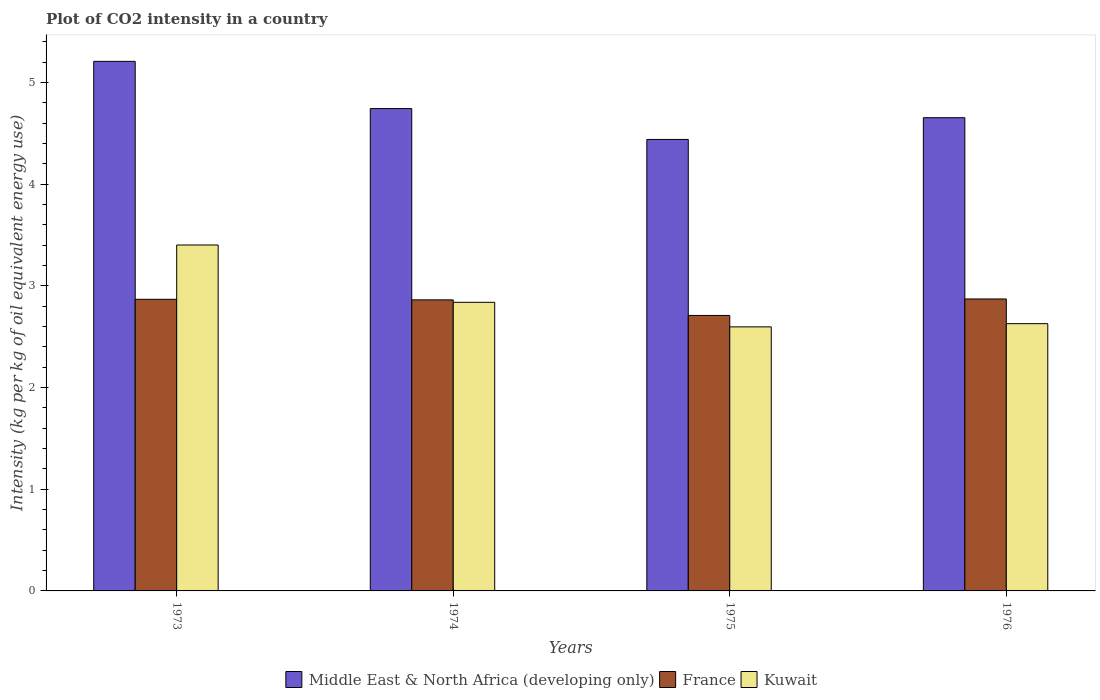How many different coloured bars are there?
Offer a very short reply. 3. How many groups of bars are there?
Give a very brief answer. 4. Are the number of bars per tick equal to the number of legend labels?
Give a very brief answer. Yes. Are the number of bars on each tick of the X-axis equal?
Provide a succinct answer. Yes. How many bars are there on the 2nd tick from the right?
Provide a short and direct response. 3. What is the label of the 4th group of bars from the left?
Offer a terse response. 1976. In how many cases, is the number of bars for a given year not equal to the number of legend labels?
Offer a terse response. 0. What is the CO2 intensity in in France in 1973?
Provide a succinct answer. 2.87. Across all years, what is the maximum CO2 intensity in in France?
Your answer should be very brief. 2.87. Across all years, what is the minimum CO2 intensity in in Middle East & North Africa (developing only)?
Offer a very short reply. 4.44. In which year was the CO2 intensity in in Middle East & North Africa (developing only) minimum?
Keep it short and to the point. 1975. What is the total CO2 intensity in in Middle East & North Africa (developing only) in the graph?
Make the answer very short. 19.05. What is the difference between the CO2 intensity in in Kuwait in 1973 and that in 1976?
Give a very brief answer. 0.77. What is the difference between the CO2 intensity in in Kuwait in 1975 and the CO2 intensity in in Middle East & North Africa (developing only) in 1973?
Ensure brevity in your answer.  -2.61. What is the average CO2 intensity in in France per year?
Give a very brief answer. 2.83. In the year 1973, what is the difference between the CO2 intensity in in Kuwait and CO2 intensity in in Middle East & North Africa (developing only)?
Keep it short and to the point. -1.81. What is the ratio of the CO2 intensity in in Middle East & North Africa (developing only) in 1973 to that in 1976?
Your answer should be compact. 1.12. Is the CO2 intensity in in Middle East & North Africa (developing only) in 1973 less than that in 1975?
Your answer should be compact. No. Is the difference between the CO2 intensity in in Kuwait in 1974 and 1975 greater than the difference between the CO2 intensity in in Middle East & North Africa (developing only) in 1974 and 1975?
Your answer should be very brief. No. What is the difference between the highest and the second highest CO2 intensity in in France?
Your answer should be very brief. 0. What is the difference between the highest and the lowest CO2 intensity in in France?
Your answer should be compact. 0.16. Is the sum of the CO2 intensity in in Middle East & North Africa (developing only) in 1973 and 1976 greater than the maximum CO2 intensity in in Kuwait across all years?
Ensure brevity in your answer.  Yes. What does the 1st bar from the left in 1976 represents?
Provide a succinct answer. Middle East & North Africa (developing only). What does the 1st bar from the right in 1975 represents?
Offer a terse response. Kuwait. Is it the case that in every year, the sum of the CO2 intensity in in France and CO2 intensity in in Kuwait is greater than the CO2 intensity in in Middle East & North Africa (developing only)?
Offer a terse response. Yes. Are all the bars in the graph horizontal?
Ensure brevity in your answer.  No. Are the values on the major ticks of Y-axis written in scientific E-notation?
Give a very brief answer. No. Does the graph contain grids?
Keep it short and to the point. No. Where does the legend appear in the graph?
Your response must be concise. Bottom center. How are the legend labels stacked?
Ensure brevity in your answer.  Horizontal. What is the title of the graph?
Offer a very short reply. Plot of CO2 intensity in a country. What is the label or title of the X-axis?
Your response must be concise. Years. What is the label or title of the Y-axis?
Provide a succinct answer. Intensity (kg per kg of oil equivalent energy use). What is the Intensity (kg per kg of oil equivalent energy use) in Middle East & North Africa (developing only) in 1973?
Ensure brevity in your answer.  5.21. What is the Intensity (kg per kg of oil equivalent energy use) of France in 1973?
Give a very brief answer. 2.87. What is the Intensity (kg per kg of oil equivalent energy use) of Kuwait in 1973?
Offer a very short reply. 3.4. What is the Intensity (kg per kg of oil equivalent energy use) of Middle East & North Africa (developing only) in 1974?
Your answer should be compact. 4.74. What is the Intensity (kg per kg of oil equivalent energy use) of France in 1974?
Offer a very short reply. 2.86. What is the Intensity (kg per kg of oil equivalent energy use) in Kuwait in 1974?
Provide a short and direct response. 2.84. What is the Intensity (kg per kg of oil equivalent energy use) of Middle East & North Africa (developing only) in 1975?
Make the answer very short. 4.44. What is the Intensity (kg per kg of oil equivalent energy use) of France in 1975?
Make the answer very short. 2.71. What is the Intensity (kg per kg of oil equivalent energy use) in Kuwait in 1975?
Offer a terse response. 2.6. What is the Intensity (kg per kg of oil equivalent energy use) in Middle East & North Africa (developing only) in 1976?
Your response must be concise. 4.65. What is the Intensity (kg per kg of oil equivalent energy use) of France in 1976?
Your response must be concise. 2.87. What is the Intensity (kg per kg of oil equivalent energy use) in Kuwait in 1976?
Offer a terse response. 2.63. Across all years, what is the maximum Intensity (kg per kg of oil equivalent energy use) in Middle East & North Africa (developing only)?
Offer a terse response. 5.21. Across all years, what is the maximum Intensity (kg per kg of oil equivalent energy use) in France?
Your answer should be very brief. 2.87. Across all years, what is the maximum Intensity (kg per kg of oil equivalent energy use) of Kuwait?
Ensure brevity in your answer.  3.4. Across all years, what is the minimum Intensity (kg per kg of oil equivalent energy use) in Middle East & North Africa (developing only)?
Offer a very short reply. 4.44. Across all years, what is the minimum Intensity (kg per kg of oil equivalent energy use) of France?
Your answer should be compact. 2.71. Across all years, what is the minimum Intensity (kg per kg of oil equivalent energy use) of Kuwait?
Provide a succinct answer. 2.6. What is the total Intensity (kg per kg of oil equivalent energy use) of Middle East & North Africa (developing only) in the graph?
Offer a terse response. 19.05. What is the total Intensity (kg per kg of oil equivalent energy use) in France in the graph?
Offer a terse response. 11.31. What is the total Intensity (kg per kg of oil equivalent energy use) of Kuwait in the graph?
Make the answer very short. 11.47. What is the difference between the Intensity (kg per kg of oil equivalent energy use) of Middle East & North Africa (developing only) in 1973 and that in 1974?
Provide a short and direct response. 0.46. What is the difference between the Intensity (kg per kg of oil equivalent energy use) in France in 1973 and that in 1974?
Provide a succinct answer. 0.01. What is the difference between the Intensity (kg per kg of oil equivalent energy use) in Kuwait in 1973 and that in 1974?
Make the answer very short. 0.56. What is the difference between the Intensity (kg per kg of oil equivalent energy use) in Middle East & North Africa (developing only) in 1973 and that in 1975?
Keep it short and to the point. 0.77. What is the difference between the Intensity (kg per kg of oil equivalent energy use) in France in 1973 and that in 1975?
Give a very brief answer. 0.16. What is the difference between the Intensity (kg per kg of oil equivalent energy use) of Kuwait in 1973 and that in 1975?
Provide a succinct answer. 0.81. What is the difference between the Intensity (kg per kg of oil equivalent energy use) in Middle East & North Africa (developing only) in 1973 and that in 1976?
Your answer should be compact. 0.55. What is the difference between the Intensity (kg per kg of oil equivalent energy use) in France in 1973 and that in 1976?
Provide a succinct answer. -0. What is the difference between the Intensity (kg per kg of oil equivalent energy use) in Kuwait in 1973 and that in 1976?
Your answer should be very brief. 0.77. What is the difference between the Intensity (kg per kg of oil equivalent energy use) of Middle East & North Africa (developing only) in 1974 and that in 1975?
Offer a terse response. 0.3. What is the difference between the Intensity (kg per kg of oil equivalent energy use) in France in 1974 and that in 1975?
Your response must be concise. 0.15. What is the difference between the Intensity (kg per kg of oil equivalent energy use) of Kuwait in 1974 and that in 1975?
Keep it short and to the point. 0.24. What is the difference between the Intensity (kg per kg of oil equivalent energy use) in Middle East & North Africa (developing only) in 1974 and that in 1976?
Your answer should be compact. 0.09. What is the difference between the Intensity (kg per kg of oil equivalent energy use) of France in 1974 and that in 1976?
Give a very brief answer. -0.01. What is the difference between the Intensity (kg per kg of oil equivalent energy use) in Kuwait in 1974 and that in 1976?
Ensure brevity in your answer.  0.21. What is the difference between the Intensity (kg per kg of oil equivalent energy use) in Middle East & North Africa (developing only) in 1975 and that in 1976?
Provide a succinct answer. -0.21. What is the difference between the Intensity (kg per kg of oil equivalent energy use) of France in 1975 and that in 1976?
Your response must be concise. -0.16. What is the difference between the Intensity (kg per kg of oil equivalent energy use) of Kuwait in 1975 and that in 1976?
Provide a succinct answer. -0.03. What is the difference between the Intensity (kg per kg of oil equivalent energy use) in Middle East & North Africa (developing only) in 1973 and the Intensity (kg per kg of oil equivalent energy use) in France in 1974?
Offer a very short reply. 2.35. What is the difference between the Intensity (kg per kg of oil equivalent energy use) of Middle East & North Africa (developing only) in 1973 and the Intensity (kg per kg of oil equivalent energy use) of Kuwait in 1974?
Your answer should be very brief. 2.37. What is the difference between the Intensity (kg per kg of oil equivalent energy use) of France in 1973 and the Intensity (kg per kg of oil equivalent energy use) of Kuwait in 1974?
Offer a terse response. 0.03. What is the difference between the Intensity (kg per kg of oil equivalent energy use) in Middle East & North Africa (developing only) in 1973 and the Intensity (kg per kg of oil equivalent energy use) in France in 1975?
Your response must be concise. 2.5. What is the difference between the Intensity (kg per kg of oil equivalent energy use) of Middle East & North Africa (developing only) in 1973 and the Intensity (kg per kg of oil equivalent energy use) of Kuwait in 1975?
Keep it short and to the point. 2.61. What is the difference between the Intensity (kg per kg of oil equivalent energy use) in France in 1973 and the Intensity (kg per kg of oil equivalent energy use) in Kuwait in 1975?
Your response must be concise. 0.27. What is the difference between the Intensity (kg per kg of oil equivalent energy use) of Middle East & North Africa (developing only) in 1973 and the Intensity (kg per kg of oil equivalent energy use) of France in 1976?
Your response must be concise. 2.34. What is the difference between the Intensity (kg per kg of oil equivalent energy use) in Middle East & North Africa (developing only) in 1973 and the Intensity (kg per kg of oil equivalent energy use) in Kuwait in 1976?
Make the answer very short. 2.58. What is the difference between the Intensity (kg per kg of oil equivalent energy use) in France in 1973 and the Intensity (kg per kg of oil equivalent energy use) in Kuwait in 1976?
Provide a short and direct response. 0.24. What is the difference between the Intensity (kg per kg of oil equivalent energy use) in Middle East & North Africa (developing only) in 1974 and the Intensity (kg per kg of oil equivalent energy use) in France in 1975?
Provide a succinct answer. 2.03. What is the difference between the Intensity (kg per kg of oil equivalent energy use) in Middle East & North Africa (developing only) in 1974 and the Intensity (kg per kg of oil equivalent energy use) in Kuwait in 1975?
Your response must be concise. 2.15. What is the difference between the Intensity (kg per kg of oil equivalent energy use) in France in 1974 and the Intensity (kg per kg of oil equivalent energy use) in Kuwait in 1975?
Offer a very short reply. 0.27. What is the difference between the Intensity (kg per kg of oil equivalent energy use) of Middle East & North Africa (developing only) in 1974 and the Intensity (kg per kg of oil equivalent energy use) of France in 1976?
Your answer should be very brief. 1.87. What is the difference between the Intensity (kg per kg of oil equivalent energy use) of Middle East & North Africa (developing only) in 1974 and the Intensity (kg per kg of oil equivalent energy use) of Kuwait in 1976?
Your response must be concise. 2.12. What is the difference between the Intensity (kg per kg of oil equivalent energy use) in France in 1974 and the Intensity (kg per kg of oil equivalent energy use) in Kuwait in 1976?
Make the answer very short. 0.23. What is the difference between the Intensity (kg per kg of oil equivalent energy use) in Middle East & North Africa (developing only) in 1975 and the Intensity (kg per kg of oil equivalent energy use) in France in 1976?
Offer a very short reply. 1.57. What is the difference between the Intensity (kg per kg of oil equivalent energy use) in Middle East & North Africa (developing only) in 1975 and the Intensity (kg per kg of oil equivalent energy use) in Kuwait in 1976?
Your answer should be compact. 1.81. What is the difference between the Intensity (kg per kg of oil equivalent energy use) of France in 1975 and the Intensity (kg per kg of oil equivalent energy use) of Kuwait in 1976?
Give a very brief answer. 0.08. What is the average Intensity (kg per kg of oil equivalent energy use) in Middle East & North Africa (developing only) per year?
Your response must be concise. 4.76. What is the average Intensity (kg per kg of oil equivalent energy use) of France per year?
Your answer should be compact. 2.83. What is the average Intensity (kg per kg of oil equivalent energy use) in Kuwait per year?
Ensure brevity in your answer.  2.87. In the year 1973, what is the difference between the Intensity (kg per kg of oil equivalent energy use) of Middle East & North Africa (developing only) and Intensity (kg per kg of oil equivalent energy use) of France?
Your response must be concise. 2.34. In the year 1973, what is the difference between the Intensity (kg per kg of oil equivalent energy use) in Middle East & North Africa (developing only) and Intensity (kg per kg of oil equivalent energy use) in Kuwait?
Keep it short and to the point. 1.81. In the year 1973, what is the difference between the Intensity (kg per kg of oil equivalent energy use) in France and Intensity (kg per kg of oil equivalent energy use) in Kuwait?
Your answer should be compact. -0.53. In the year 1974, what is the difference between the Intensity (kg per kg of oil equivalent energy use) of Middle East & North Africa (developing only) and Intensity (kg per kg of oil equivalent energy use) of France?
Keep it short and to the point. 1.88. In the year 1974, what is the difference between the Intensity (kg per kg of oil equivalent energy use) of Middle East & North Africa (developing only) and Intensity (kg per kg of oil equivalent energy use) of Kuwait?
Your answer should be compact. 1.91. In the year 1974, what is the difference between the Intensity (kg per kg of oil equivalent energy use) in France and Intensity (kg per kg of oil equivalent energy use) in Kuwait?
Give a very brief answer. 0.02. In the year 1975, what is the difference between the Intensity (kg per kg of oil equivalent energy use) of Middle East & North Africa (developing only) and Intensity (kg per kg of oil equivalent energy use) of France?
Your response must be concise. 1.73. In the year 1975, what is the difference between the Intensity (kg per kg of oil equivalent energy use) in Middle East & North Africa (developing only) and Intensity (kg per kg of oil equivalent energy use) in Kuwait?
Your response must be concise. 1.84. In the year 1975, what is the difference between the Intensity (kg per kg of oil equivalent energy use) in France and Intensity (kg per kg of oil equivalent energy use) in Kuwait?
Provide a short and direct response. 0.11. In the year 1976, what is the difference between the Intensity (kg per kg of oil equivalent energy use) of Middle East & North Africa (developing only) and Intensity (kg per kg of oil equivalent energy use) of France?
Your answer should be very brief. 1.78. In the year 1976, what is the difference between the Intensity (kg per kg of oil equivalent energy use) in Middle East & North Africa (developing only) and Intensity (kg per kg of oil equivalent energy use) in Kuwait?
Your response must be concise. 2.03. In the year 1976, what is the difference between the Intensity (kg per kg of oil equivalent energy use) in France and Intensity (kg per kg of oil equivalent energy use) in Kuwait?
Keep it short and to the point. 0.24. What is the ratio of the Intensity (kg per kg of oil equivalent energy use) in Middle East & North Africa (developing only) in 1973 to that in 1974?
Provide a short and direct response. 1.1. What is the ratio of the Intensity (kg per kg of oil equivalent energy use) of Kuwait in 1973 to that in 1974?
Your response must be concise. 1.2. What is the ratio of the Intensity (kg per kg of oil equivalent energy use) of Middle East & North Africa (developing only) in 1973 to that in 1975?
Provide a short and direct response. 1.17. What is the ratio of the Intensity (kg per kg of oil equivalent energy use) in France in 1973 to that in 1975?
Provide a succinct answer. 1.06. What is the ratio of the Intensity (kg per kg of oil equivalent energy use) in Kuwait in 1973 to that in 1975?
Give a very brief answer. 1.31. What is the ratio of the Intensity (kg per kg of oil equivalent energy use) of Middle East & North Africa (developing only) in 1973 to that in 1976?
Offer a terse response. 1.12. What is the ratio of the Intensity (kg per kg of oil equivalent energy use) in France in 1973 to that in 1976?
Your response must be concise. 1. What is the ratio of the Intensity (kg per kg of oil equivalent energy use) in Kuwait in 1973 to that in 1976?
Keep it short and to the point. 1.29. What is the ratio of the Intensity (kg per kg of oil equivalent energy use) of Middle East & North Africa (developing only) in 1974 to that in 1975?
Give a very brief answer. 1.07. What is the ratio of the Intensity (kg per kg of oil equivalent energy use) in France in 1974 to that in 1975?
Your answer should be very brief. 1.06. What is the ratio of the Intensity (kg per kg of oil equivalent energy use) in Kuwait in 1974 to that in 1975?
Your response must be concise. 1.09. What is the ratio of the Intensity (kg per kg of oil equivalent energy use) of Middle East & North Africa (developing only) in 1974 to that in 1976?
Your answer should be very brief. 1.02. What is the ratio of the Intensity (kg per kg of oil equivalent energy use) of France in 1974 to that in 1976?
Ensure brevity in your answer.  1. What is the ratio of the Intensity (kg per kg of oil equivalent energy use) of Kuwait in 1974 to that in 1976?
Make the answer very short. 1.08. What is the ratio of the Intensity (kg per kg of oil equivalent energy use) of Middle East & North Africa (developing only) in 1975 to that in 1976?
Give a very brief answer. 0.95. What is the ratio of the Intensity (kg per kg of oil equivalent energy use) in France in 1975 to that in 1976?
Your response must be concise. 0.94. What is the difference between the highest and the second highest Intensity (kg per kg of oil equivalent energy use) of Middle East & North Africa (developing only)?
Keep it short and to the point. 0.46. What is the difference between the highest and the second highest Intensity (kg per kg of oil equivalent energy use) of France?
Ensure brevity in your answer.  0. What is the difference between the highest and the second highest Intensity (kg per kg of oil equivalent energy use) in Kuwait?
Give a very brief answer. 0.56. What is the difference between the highest and the lowest Intensity (kg per kg of oil equivalent energy use) in Middle East & North Africa (developing only)?
Your answer should be very brief. 0.77. What is the difference between the highest and the lowest Intensity (kg per kg of oil equivalent energy use) in France?
Keep it short and to the point. 0.16. What is the difference between the highest and the lowest Intensity (kg per kg of oil equivalent energy use) in Kuwait?
Your answer should be very brief. 0.81. 